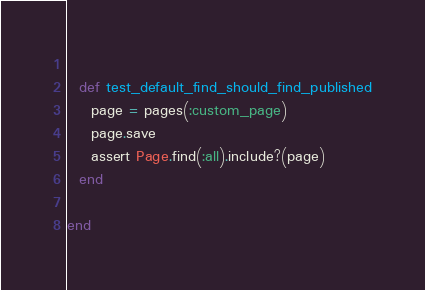<code> <loc_0><loc_0><loc_500><loc_500><_Ruby_>  
  def test_default_find_should_find_published
    page = pages(:custom_page)
    page.save
    assert Page.find(:all).include?(page)    
  end

end
</code> 